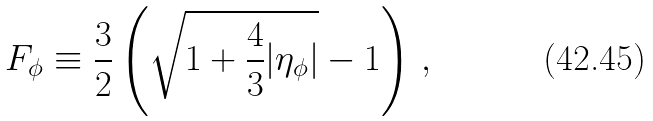Convert formula to latex. <formula><loc_0><loc_0><loc_500><loc_500>F _ { \phi } \equiv \frac { 3 } { 2 } \left ( \sqrt { 1 + \frac { 4 } { 3 } | \eta _ { \phi } | } - 1 \right ) \, ,</formula> 